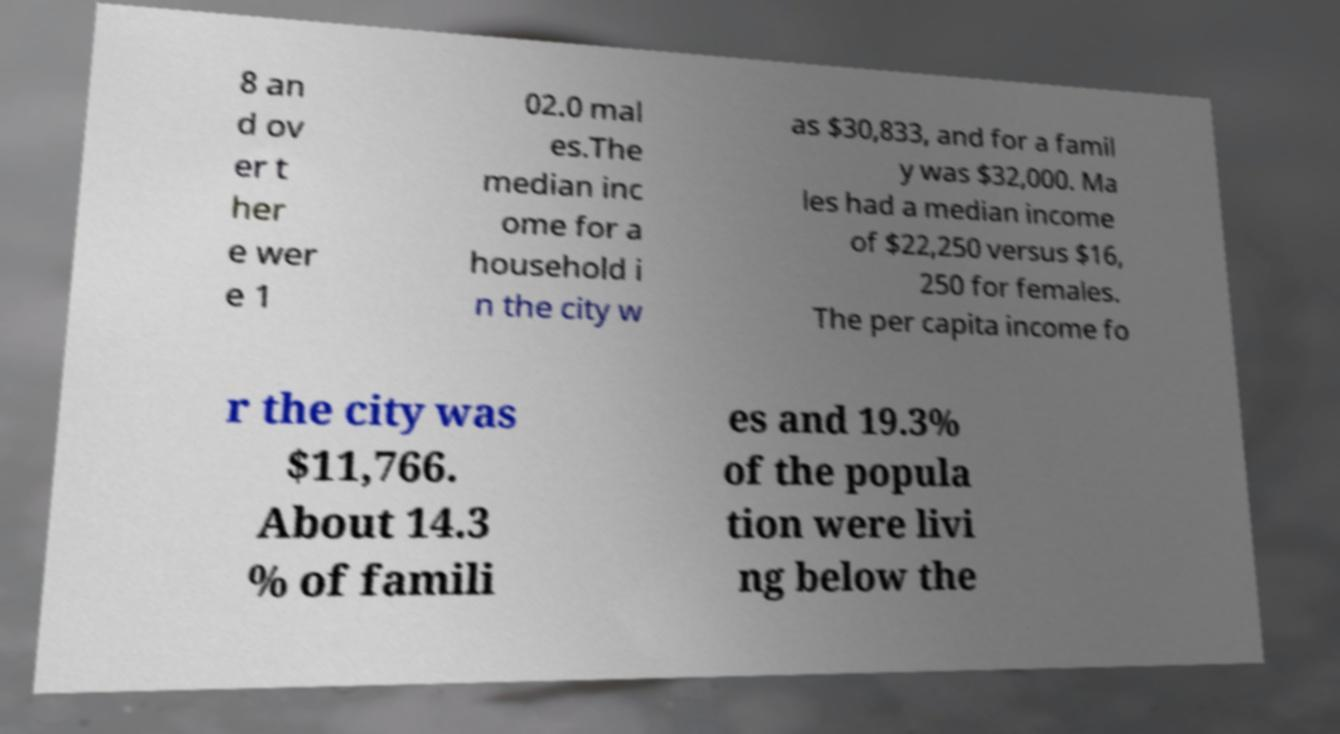Could you assist in decoding the text presented in this image and type it out clearly? 8 an d ov er t her e wer e 1 02.0 mal es.The median inc ome for a household i n the city w as $30,833, and for a famil y was $32,000. Ma les had a median income of $22,250 versus $16, 250 for females. The per capita income fo r the city was $11,766. About 14.3 % of famili es and 19.3% of the popula tion were livi ng below the 